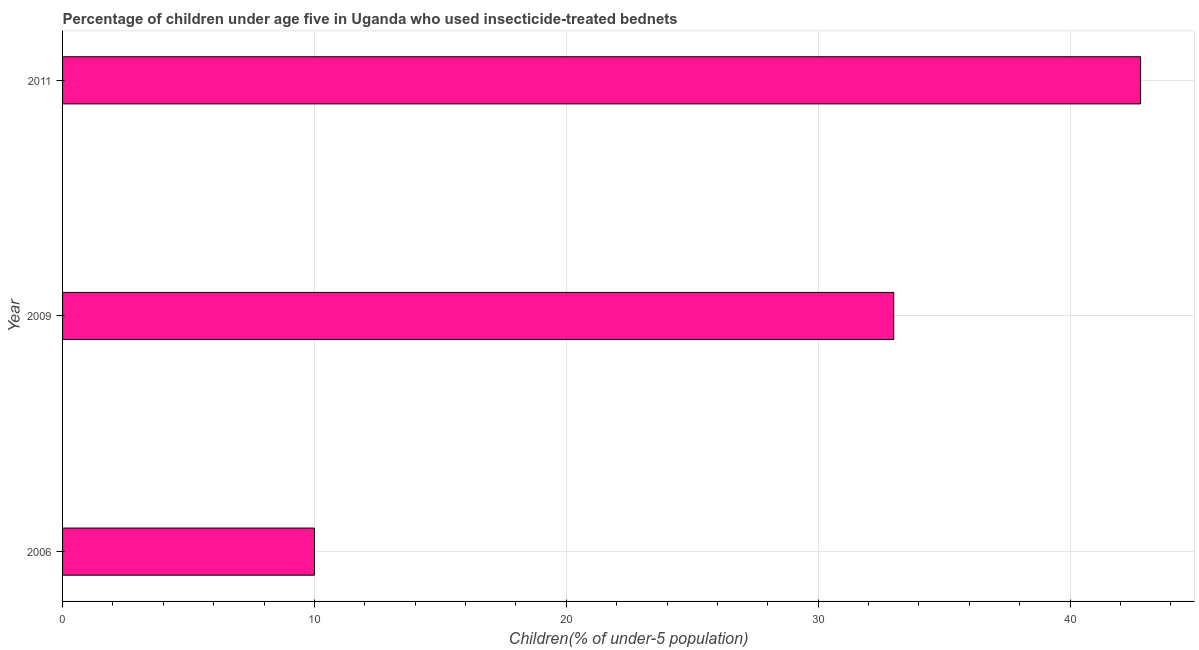Does the graph contain any zero values?
Offer a terse response. No. Does the graph contain grids?
Offer a very short reply. Yes. What is the title of the graph?
Your response must be concise. Percentage of children under age five in Uganda who used insecticide-treated bednets. What is the label or title of the X-axis?
Offer a terse response. Children(% of under-5 population). Across all years, what is the maximum percentage of children who use of insecticide-treated bed nets?
Provide a succinct answer. 42.8. Across all years, what is the minimum percentage of children who use of insecticide-treated bed nets?
Give a very brief answer. 10. In which year was the percentage of children who use of insecticide-treated bed nets minimum?
Provide a short and direct response. 2006. What is the sum of the percentage of children who use of insecticide-treated bed nets?
Offer a terse response. 85.8. What is the average percentage of children who use of insecticide-treated bed nets per year?
Your answer should be compact. 28.6. What is the median percentage of children who use of insecticide-treated bed nets?
Keep it short and to the point. 33. In how many years, is the percentage of children who use of insecticide-treated bed nets greater than 36 %?
Ensure brevity in your answer.  1. Do a majority of the years between 2011 and 2006 (inclusive) have percentage of children who use of insecticide-treated bed nets greater than 10 %?
Your answer should be compact. Yes. What is the ratio of the percentage of children who use of insecticide-treated bed nets in 2009 to that in 2011?
Your answer should be compact. 0.77. Is the difference between the percentage of children who use of insecticide-treated bed nets in 2009 and 2011 greater than the difference between any two years?
Provide a short and direct response. No. What is the difference between the highest and the lowest percentage of children who use of insecticide-treated bed nets?
Make the answer very short. 32.8. In how many years, is the percentage of children who use of insecticide-treated bed nets greater than the average percentage of children who use of insecticide-treated bed nets taken over all years?
Your answer should be compact. 2. How many bars are there?
Your answer should be compact. 3. Are all the bars in the graph horizontal?
Make the answer very short. Yes. What is the difference between two consecutive major ticks on the X-axis?
Your answer should be very brief. 10. What is the Children(% of under-5 population) of 2009?
Your answer should be very brief. 33. What is the Children(% of under-5 population) of 2011?
Your answer should be very brief. 42.8. What is the difference between the Children(% of under-5 population) in 2006 and 2009?
Make the answer very short. -23. What is the difference between the Children(% of under-5 population) in 2006 and 2011?
Give a very brief answer. -32.8. What is the ratio of the Children(% of under-5 population) in 2006 to that in 2009?
Your answer should be compact. 0.3. What is the ratio of the Children(% of under-5 population) in 2006 to that in 2011?
Your response must be concise. 0.23. What is the ratio of the Children(% of under-5 population) in 2009 to that in 2011?
Your answer should be very brief. 0.77. 